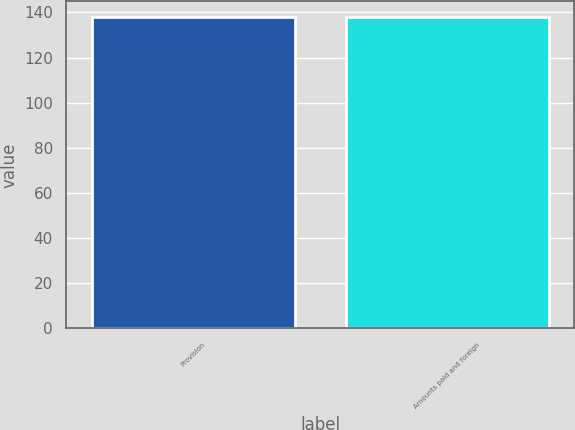Convert chart. <chart><loc_0><loc_0><loc_500><loc_500><bar_chart><fcel>Provision<fcel>Amounts paid and foreign<nl><fcel>138<fcel>138.1<nl></chart> 